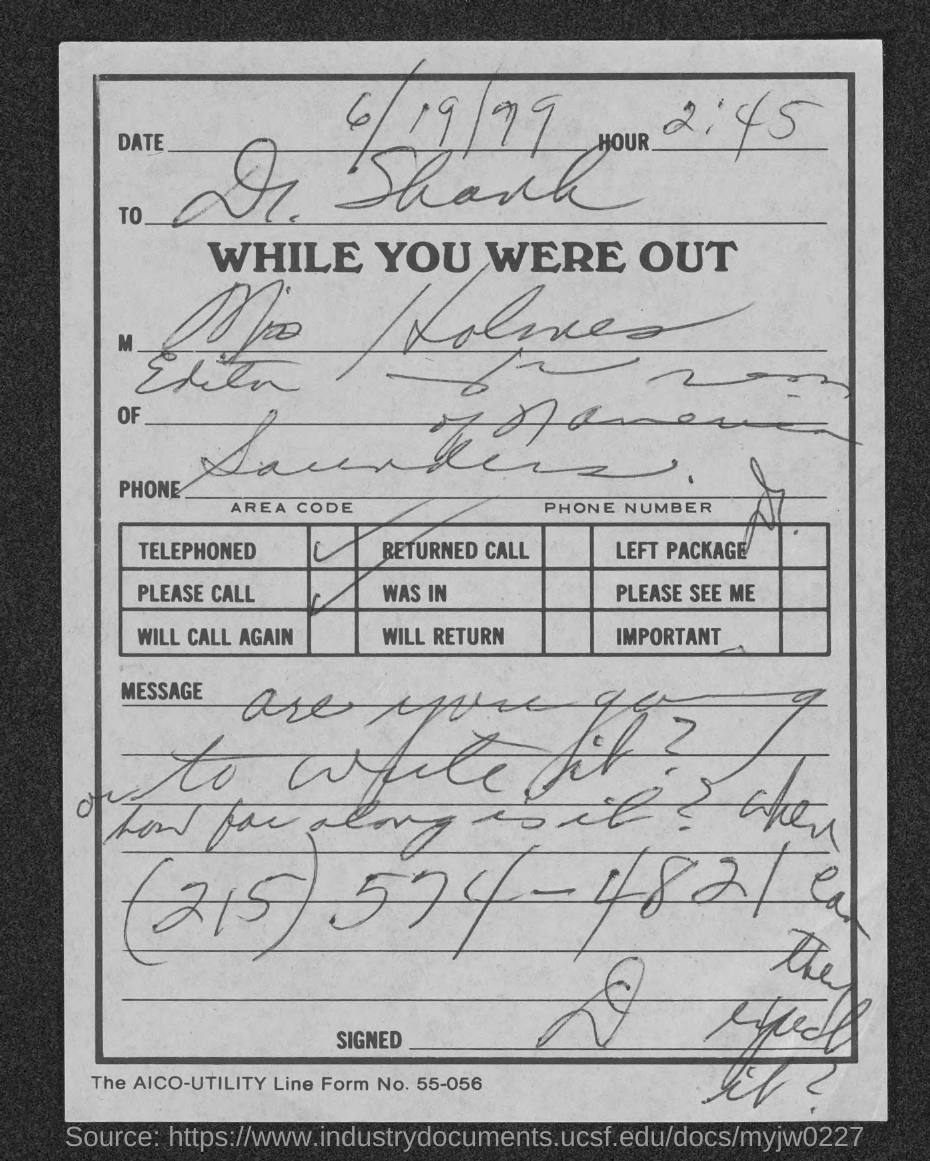What is the aico-utility line form no.?
Provide a short and direct response. 55-056. 